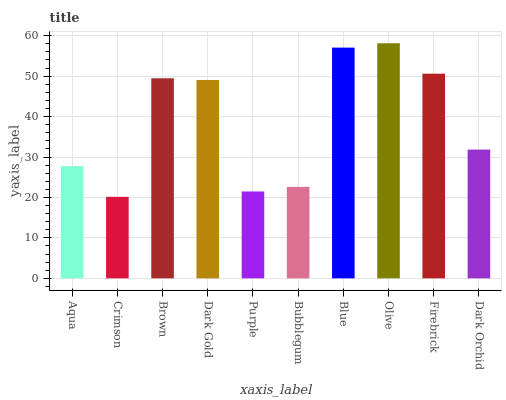Is Crimson the minimum?
Answer yes or no. Yes. Is Olive the maximum?
Answer yes or no. Yes. Is Brown the minimum?
Answer yes or no. No. Is Brown the maximum?
Answer yes or no. No. Is Brown greater than Crimson?
Answer yes or no. Yes. Is Crimson less than Brown?
Answer yes or no. Yes. Is Crimson greater than Brown?
Answer yes or no. No. Is Brown less than Crimson?
Answer yes or no. No. Is Dark Gold the high median?
Answer yes or no. Yes. Is Dark Orchid the low median?
Answer yes or no. Yes. Is Firebrick the high median?
Answer yes or no. No. Is Crimson the low median?
Answer yes or no. No. 